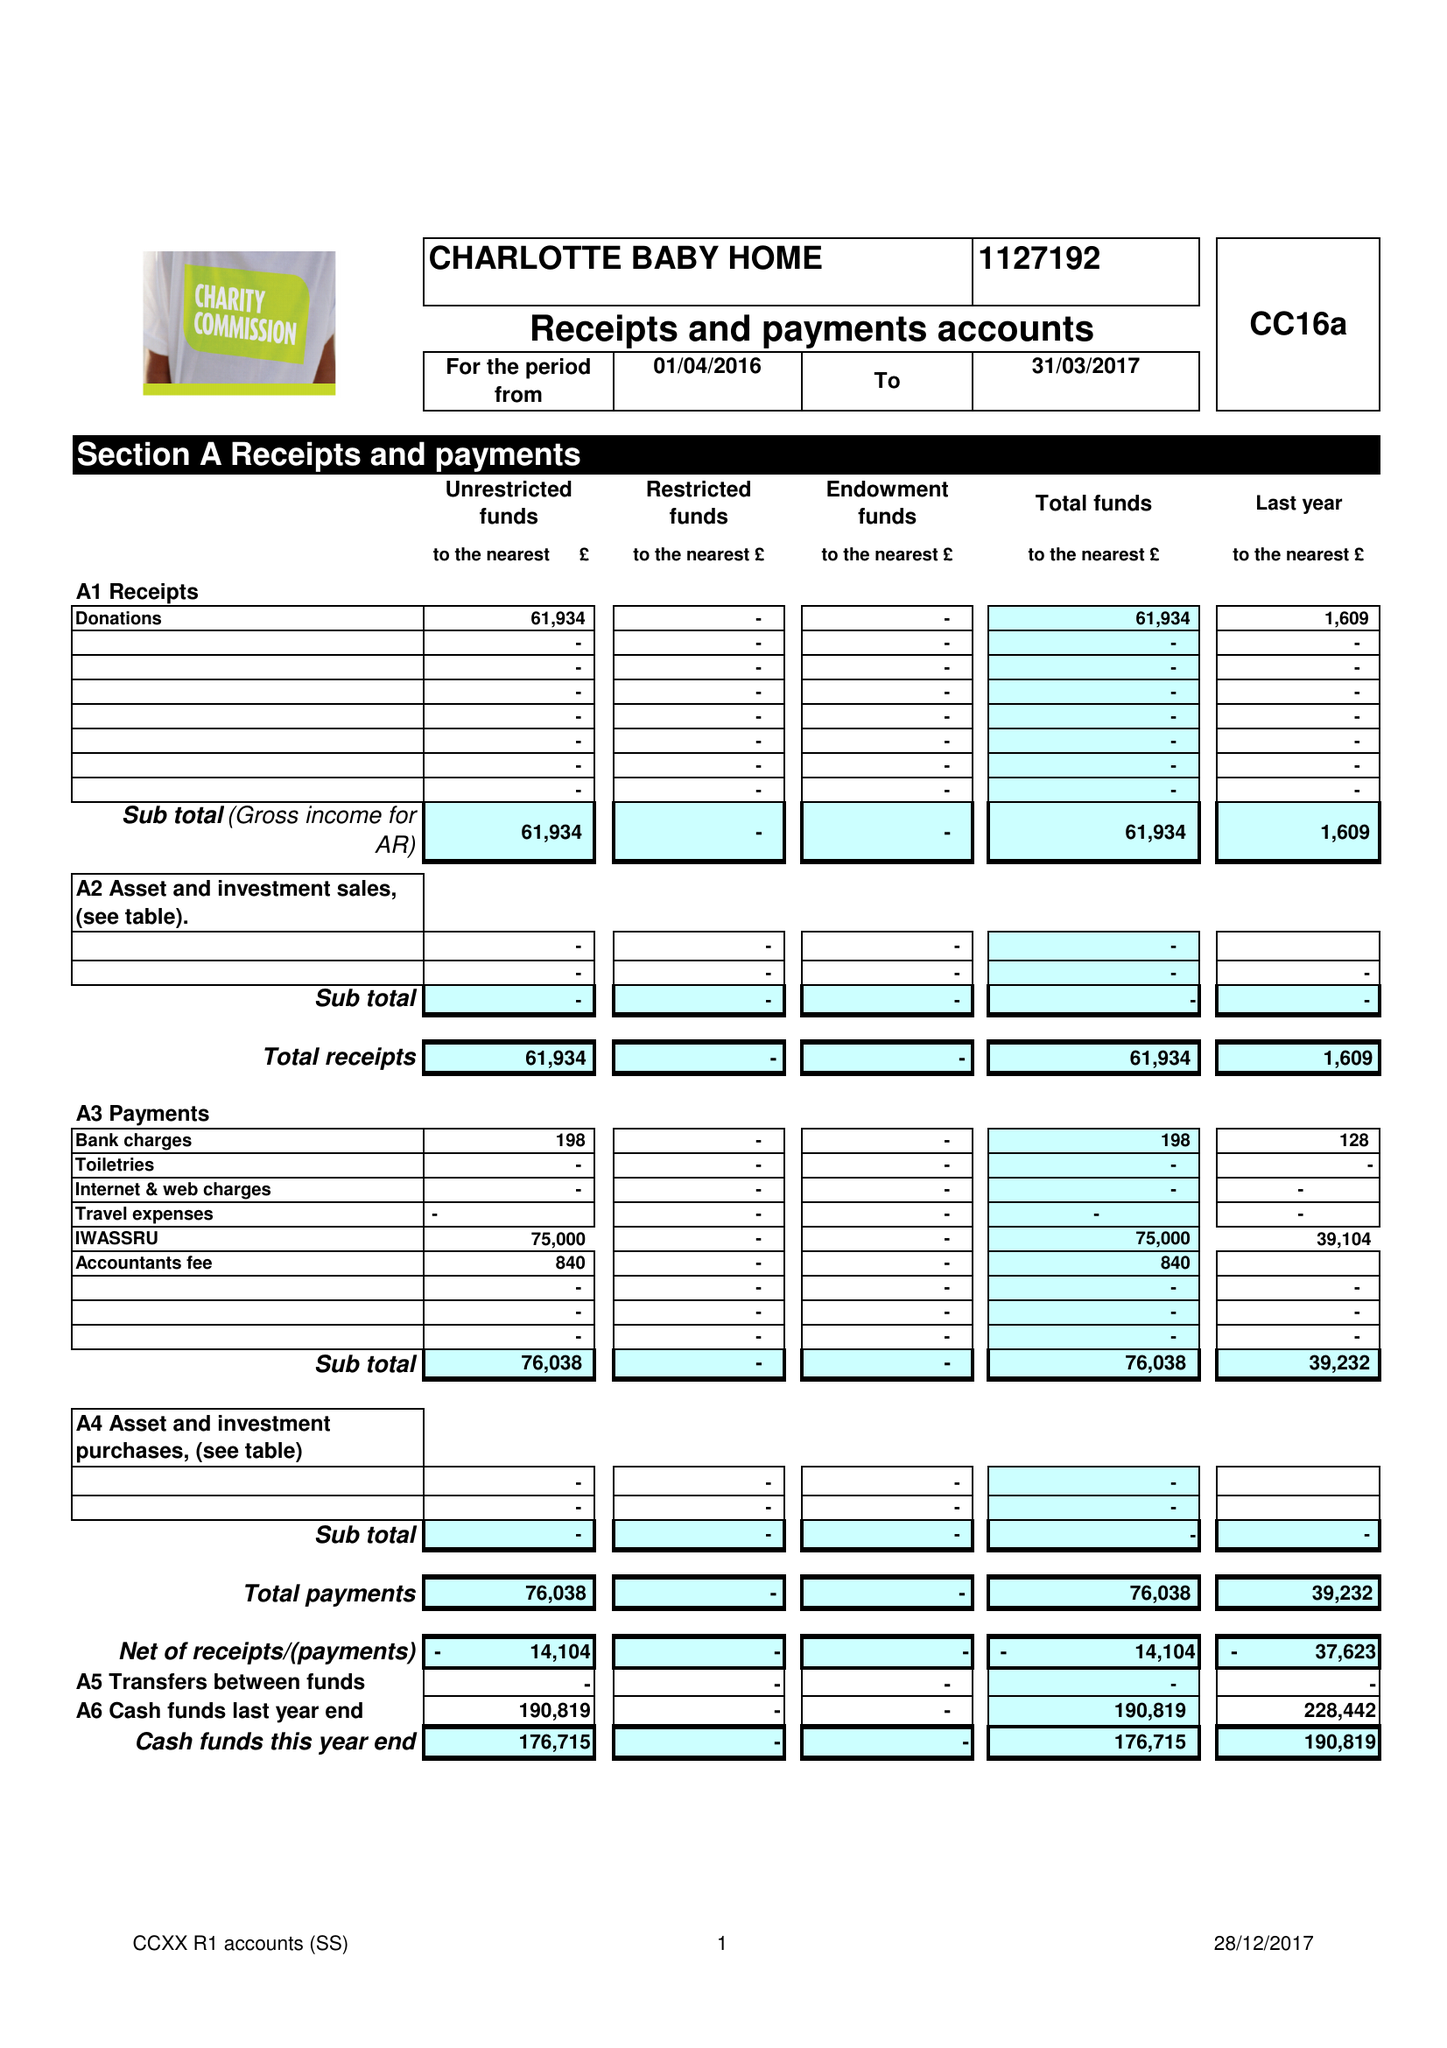What is the value for the spending_annually_in_british_pounds?
Answer the question using a single word or phrase. 76038.00 